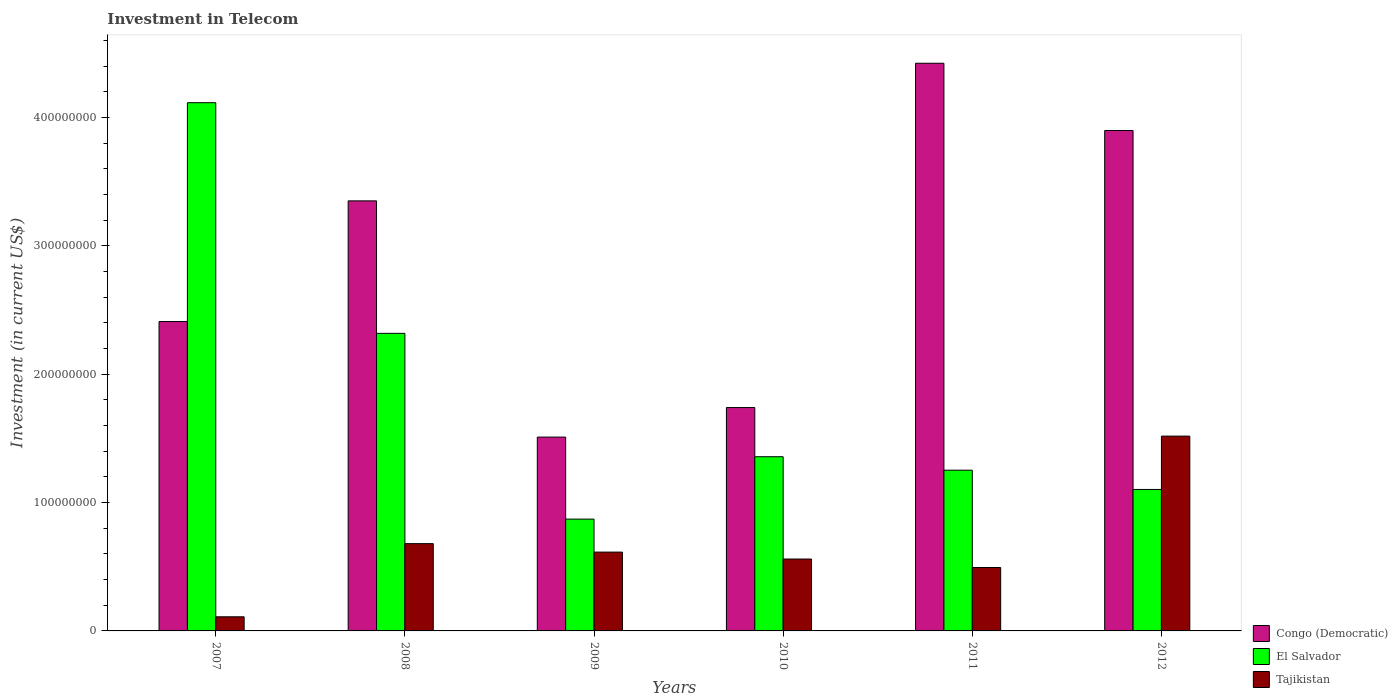Are the number of bars per tick equal to the number of legend labels?
Your answer should be very brief. Yes. Are the number of bars on each tick of the X-axis equal?
Your response must be concise. Yes. How many bars are there on the 6th tick from the left?
Offer a terse response. 3. In how many cases, is the number of bars for a given year not equal to the number of legend labels?
Your response must be concise. 0. What is the amount invested in telecom in Congo (Democratic) in 2009?
Your response must be concise. 1.51e+08. Across all years, what is the maximum amount invested in telecom in Tajikistan?
Offer a terse response. 1.52e+08. Across all years, what is the minimum amount invested in telecom in El Salvador?
Your answer should be compact. 8.71e+07. In which year was the amount invested in telecom in Congo (Democratic) minimum?
Offer a terse response. 2009. What is the total amount invested in telecom in El Salvador in the graph?
Your answer should be very brief. 1.10e+09. What is the difference between the amount invested in telecom in Congo (Democratic) in 2007 and that in 2012?
Keep it short and to the point. -1.49e+08. What is the difference between the amount invested in telecom in El Salvador in 2008 and the amount invested in telecom in Tajikistan in 2009?
Make the answer very short. 1.70e+08. What is the average amount invested in telecom in El Salvador per year?
Your answer should be compact. 1.84e+08. In the year 2011, what is the difference between the amount invested in telecom in Tajikistan and amount invested in telecom in El Salvador?
Make the answer very short. -7.58e+07. In how many years, is the amount invested in telecom in Congo (Democratic) greater than 60000000 US$?
Keep it short and to the point. 6. What is the ratio of the amount invested in telecom in Tajikistan in 2009 to that in 2011?
Your response must be concise. 1.24. Is the amount invested in telecom in Congo (Democratic) in 2010 less than that in 2012?
Offer a terse response. Yes. Is the difference between the amount invested in telecom in Tajikistan in 2011 and 2012 greater than the difference between the amount invested in telecom in El Salvador in 2011 and 2012?
Provide a succinct answer. No. What is the difference between the highest and the second highest amount invested in telecom in Congo (Democratic)?
Give a very brief answer. 5.24e+07. What is the difference between the highest and the lowest amount invested in telecom in Congo (Democratic)?
Give a very brief answer. 2.91e+08. What does the 2nd bar from the left in 2007 represents?
Offer a very short reply. El Salvador. What does the 3rd bar from the right in 2007 represents?
Provide a succinct answer. Congo (Democratic). How many bars are there?
Give a very brief answer. 18. Are all the bars in the graph horizontal?
Make the answer very short. No. Does the graph contain grids?
Keep it short and to the point. No. Where does the legend appear in the graph?
Provide a succinct answer. Bottom right. How many legend labels are there?
Offer a terse response. 3. What is the title of the graph?
Provide a succinct answer. Investment in Telecom. What is the label or title of the Y-axis?
Offer a very short reply. Investment (in current US$). What is the Investment (in current US$) in Congo (Democratic) in 2007?
Make the answer very short. 2.41e+08. What is the Investment (in current US$) of El Salvador in 2007?
Provide a short and direct response. 4.11e+08. What is the Investment (in current US$) of Tajikistan in 2007?
Provide a succinct answer. 1.10e+07. What is the Investment (in current US$) in Congo (Democratic) in 2008?
Provide a succinct answer. 3.35e+08. What is the Investment (in current US$) in El Salvador in 2008?
Keep it short and to the point. 2.32e+08. What is the Investment (in current US$) in Tajikistan in 2008?
Offer a terse response. 6.80e+07. What is the Investment (in current US$) in Congo (Democratic) in 2009?
Provide a succinct answer. 1.51e+08. What is the Investment (in current US$) of El Salvador in 2009?
Offer a terse response. 8.71e+07. What is the Investment (in current US$) in Tajikistan in 2009?
Offer a terse response. 6.14e+07. What is the Investment (in current US$) of Congo (Democratic) in 2010?
Provide a short and direct response. 1.74e+08. What is the Investment (in current US$) of El Salvador in 2010?
Provide a short and direct response. 1.36e+08. What is the Investment (in current US$) of Tajikistan in 2010?
Keep it short and to the point. 5.60e+07. What is the Investment (in current US$) in Congo (Democratic) in 2011?
Give a very brief answer. 4.42e+08. What is the Investment (in current US$) of El Salvador in 2011?
Provide a succinct answer. 1.25e+08. What is the Investment (in current US$) of Tajikistan in 2011?
Your response must be concise. 4.94e+07. What is the Investment (in current US$) in Congo (Democratic) in 2012?
Provide a short and direct response. 3.90e+08. What is the Investment (in current US$) in El Salvador in 2012?
Your answer should be very brief. 1.10e+08. What is the Investment (in current US$) in Tajikistan in 2012?
Keep it short and to the point. 1.52e+08. Across all years, what is the maximum Investment (in current US$) in Congo (Democratic)?
Make the answer very short. 4.42e+08. Across all years, what is the maximum Investment (in current US$) of El Salvador?
Keep it short and to the point. 4.11e+08. Across all years, what is the maximum Investment (in current US$) of Tajikistan?
Provide a succinct answer. 1.52e+08. Across all years, what is the minimum Investment (in current US$) in Congo (Democratic)?
Provide a succinct answer. 1.51e+08. Across all years, what is the minimum Investment (in current US$) of El Salvador?
Offer a terse response. 8.71e+07. Across all years, what is the minimum Investment (in current US$) of Tajikistan?
Offer a very short reply. 1.10e+07. What is the total Investment (in current US$) in Congo (Democratic) in the graph?
Offer a terse response. 1.73e+09. What is the total Investment (in current US$) of El Salvador in the graph?
Make the answer very short. 1.10e+09. What is the total Investment (in current US$) in Tajikistan in the graph?
Your answer should be compact. 3.98e+08. What is the difference between the Investment (in current US$) of Congo (Democratic) in 2007 and that in 2008?
Give a very brief answer. -9.40e+07. What is the difference between the Investment (in current US$) of El Salvador in 2007 and that in 2008?
Provide a short and direct response. 1.80e+08. What is the difference between the Investment (in current US$) in Tajikistan in 2007 and that in 2008?
Your answer should be compact. -5.70e+07. What is the difference between the Investment (in current US$) in Congo (Democratic) in 2007 and that in 2009?
Your answer should be very brief. 9.00e+07. What is the difference between the Investment (in current US$) of El Salvador in 2007 and that in 2009?
Your answer should be compact. 3.24e+08. What is the difference between the Investment (in current US$) in Tajikistan in 2007 and that in 2009?
Keep it short and to the point. -5.04e+07. What is the difference between the Investment (in current US$) of Congo (Democratic) in 2007 and that in 2010?
Offer a very short reply. 6.70e+07. What is the difference between the Investment (in current US$) of El Salvador in 2007 and that in 2010?
Your response must be concise. 2.76e+08. What is the difference between the Investment (in current US$) of Tajikistan in 2007 and that in 2010?
Your answer should be compact. -4.50e+07. What is the difference between the Investment (in current US$) in Congo (Democratic) in 2007 and that in 2011?
Provide a succinct answer. -2.01e+08. What is the difference between the Investment (in current US$) of El Salvador in 2007 and that in 2011?
Give a very brief answer. 2.86e+08. What is the difference between the Investment (in current US$) of Tajikistan in 2007 and that in 2011?
Your answer should be very brief. -3.84e+07. What is the difference between the Investment (in current US$) in Congo (Democratic) in 2007 and that in 2012?
Provide a short and direct response. -1.49e+08. What is the difference between the Investment (in current US$) of El Salvador in 2007 and that in 2012?
Offer a terse response. 3.01e+08. What is the difference between the Investment (in current US$) of Tajikistan in 2007 and that in 2012?
Ensure brevity in your answer.  -1.41e+08. What is the difference between the Investment (in current US$) in Congo (Democratic) in 2008 and that in 2009?
Provide a succinct answer. 1.84e+08. What is the difference between the Investment (in current US$) of El Salvador in 2008 and that in 2009?
Provide a succinct answer. 1.45e+08. What is the difference between the Investment (in current US$) in Tajikistan in 2008 and that in 2009?
Offer a terse response. 6.60e+06. What is the difference between the Investment (in current US$) of Congo (Democratic) in 2008 and that in 2010?
Your answer should be compact. 1.61e+08. What is the difference between the Investment (in current US$) of El Salvador in 2008 and that in 2010?
Ensure brevity in your answer.  9.61e+07. What is the difference between the Investment (in current US$) in Congo (Democratic) in 2008 and that in 2011?
Your response must be concise. -1.07e+08. What is the difference between the Investment (in current US$) of El Salvador in 2008 and that in 2011?
Offer a very short reply. 1.07e+08. What is the difference between the Investment (in current US$) of Tajikistan in 2008 and that in 2011?
Your answer should be compact. 1.86e+07. What is the difference between the Investment (in current US$) in Congo (Democratic) in 2008 and that in 2012?
Make the answer very short. -5.48e+07. What is the difference between the Investment (in current US$) of El Salvador in 2008 and that in 2012?
Provide a short and direct response. 1.22e+08. What is the difference between the Investment (in current US$) of Tajikistan in 2008 and that in 2012?
Give a very brief answer. -8.38e+07. What is the difference between the Investment (in current US$) in Congo (Democratic) in 2009 and that in 2010?
Your answer should be very brief. -2.30e+07. What is the difference between the Investment (in current US$) in El Salvador in 2009 and that in 2010?
Your answer should be very brief. -4.86e+07. What is the difference between the Investment (in current US$) in Tajikistan in 2009 and that in 2010?
Keep it short and to the point. 5.40e+06. What is the difference between the Investment (in current US$) of Congo (Democratic) in 2009 and that in 2011?
Give a very brief answer. -2.91e+08. What is the difference between the Investment (in current US$) of El Salvador in 2009 and that in 2011?
Offer a terse response. -3.81e+07. What is the difference between the Investment (in current US$) of Tajikistan in 2009 and that in 2011?
Provide a succinct answer. 1.20e+07. What is the difference between the Investment (in current US$) of Congo (Democratic) in 2009 and that in 2012?
Provide a succinct answer. -2.39e+08. What is the difference between the Investment (in current US$) of El Salvador in 2009 and that in 2012?
Provide a short and direct response. -2.31e+07. What is the difference between the Investment (in current US$) of Tajikistan in 2009 and that in 2012?
Ensure brevity in your answer.  -9.04e+07. What is the difference between the Investment (in current US$) in Congo (Democratic) in 2010 and that in 2011?
Give a very brief answer. -2.68e+08. What is the difference between the Investment (in current US$) of El Salvador in 2010 and that in 2011?
Your answer should be very brief. 1.05e+07. What is the difference between the Investment (in current US$) of Tajikistan in 2010 and that in 2011?
Provide a succinct answer. 6.60e+06. What is the difference between the Investment (in current US$) of Congo (Democratic) in 2010 and that in 2012?
Provide a succinct answer. -2.16e+08. What is the difference between the Investment (in current US$) in El Salvador in 2010 and that in 2012?
Offer a very short reply. 2.55e+07. What is the difference between the Investment (in current US$) in Tajikistan in 2010 and that in 2012?
Keep it short and to the point. -9.58e+07. What is the difference between the Investment (in current US$) of Congo (Democratic) in 2011 and that in 2012?
Give a very brief answer. 5.24e+07. What is the difference between the Investment (in current US$) of El Salvador in 2011 and that in 2012?
Provide a short and direct response. 1.50e+07. What is the difference between the Investment (in current US$) of Tajikistan in 2011 and that in 2012?
Provide a short and direct response. -1.02e+08. What is the difference between the Investment (in current US$) in Congo (Democratic) in 2007 and the Investment (in current US$) in El Salvador in 2008?
Give a very brief answer. 9.20e+06. What is the difference between the Investment (in current US$) in Congo (Democratic) in 2007 and the Investment (in current US$) in Tajikistan in 2008?
Provide a succinct answer. 1.73e+08. What is the difference between the Investment (in current US$) of El Salvador in 2007 and the Investment (in current US$) of Tajikistan in 2008?
Ensure brevity in your answer.  3.43e+08. What is the difference between the Investment (in current US$) in Congo (Democratic) in 2007 and the Investment (in current US$) in El Salvador in 2009?
Offer a terse response. 1.54e+08. What is the difference between the Investment (in current US$) in Congo (Democratic) in 2007 and the Investment (in current US$) in Tajikistan in 2009?
Your answer should be very brief. 1.80e+08. What is the difference between the Investment (in current US$) of El Salvador in 2007 and the Investment (in current US$) of Tajikistan in 2009?
Your answer should be compact. 3.50e+08. What is the difference between the Investment (in current US$) in Congo (Democratic) in 2007 and the Investment (in current US$) in El Salvador in 2010?
Give a very brief answer. 1.05e+08. What is the difference between the Investment (in current US$) in Congo (Democratic) in 2007 and the Investment (in current US$) in Tajikistan in 2010?
Offer a terse response. 1.85e+08. What is the difference between the Investment (in current US$) of El Salvador in 2007 and the Investment (in current US$) of Tajikistan in 2010?
Offer a very short reply. 3.55e+08. What is the difference between the Investment (in current US$) in Congo (Democratic) in 2007 and the Investment (in current US$) in El Salvador in 2011?
Provide a succinct answer. 1.16e+08. What is the difference between the Investment (in current US$) in Congo (Democratic) in 2007 and the Investment (in current US$) in Tajikistan in 2011?
Offer a terse response. 1.92e+08. What is the difference between the Investment (in current US$) in El Salvador in 2007 and the Investment (in current US$) in Tajikistan in 2011?
Provide a short and direct response. 3.62e+08. What is the difference between the Investment (in current US$) in Congo (Democratic) in 2007 and the Investment (in current US$) in El Salvador in 2012?
Give a very brief answer. 1.31e+08. What is the difference between the Investment (in current US$) of Congo (Democratic) in 2007 and the Investment (in current US$) of Tajikistan in 2012?
Offer a very short reply. 8.92e+07. What is the difference between the Investment (in current US$) of El Salvador in 2007 and the Investment (in current US$) of Tajikistan in 2012?
Give a very brief answer. 2.60e+08. What is the difference between the Investment (in current US$) in Congo (Democratic) in 2008 and the Investment (in current US$) in El Salvador in 2009?
Offer a terse response. 2.48e+08. What is the difference between the Investment (in current US$) of Congo (Democratic) in 2008 and the Investment (in current US$) of Tajikistan in 2009?
Your response must be concise. 2.74e+08. What is the difference between the Investment (in current US$) of El Salvador in 2008 and the Investment (in current US$) of Tajikistan in 2009?
Give a very brief answer. 1.70e+08. What is the difference between the Investment (in current US$) of Congo (Democratic) in 2008 and the Investment (in current US$) of El Salvador in 2010?
Ensure brevity in your answer.  1.99e+08. What is the difference between the Investment (in current US$) in Congo (Democratic) in 2008 and the Investment (in current US$) in Tajikistan in 2010?
Your response must be concise. 2.79e+08. What is the difference between the Investment (in current US$) of El Salvador in 2008 and the Investment (in current US$) of Tajikistan in 2010?
Offer a terse response. 1.76e+08. What is the difference between the Investment (in current US$) of Congo (Democratic) in 2008 and the Investment (in current US$) of El Salvador in 2011?
Your answer should be compact. 2.10e+08. What is the difference between the Investment (in current US$) in Congo (Democratic) in 2008 and the Investment (in current US$) in Tajikistan in 2011?
Give a very brief answer. 2.86e+08. What is the difference between the Investment (in current US$) of El Salvador in 2008 and the Investment (in current US$) of Tajikistan in 2011?
Ensure brevity in your answer.  1.82e+08. What is the difference between the Investment (in current US$) in Congo (Democratic) in 2008 and the Investment (in current US$) in El Salvador in 2012?
Make the answer very short. 2.25e+08. What is the difference between the Investment (in current US$) of Congo (Democratic) in 2008 and the Investment (in current US$) of Tajikistan in 2012?
Offer a very short reply. 1.83e+08. What is the difference between the Investment (in current US$) of El Salvador in 2008 and the Investment (in current US$) of Tajikistan in 2012?
Your response must be concise. 8.00e+07. What is the difference between the Investment (in current US$) in Congo (Democratic) in 2009 and the Investment (in current US$) in El Salvador in 2010?
Make the answer very short. 1.53e+07. What is the difference between the Investment (in current US$) of Congo (Democratic) in 2009 and the Investment (in current US$) of Tajikistan in 2010?
Make the answer very short. 9.50e+07. What is the difference between the Investment (in current US$) of El Salvador in 2009 and the Investment (in current US$) of Tajikistan in 2010?
Make the answer very short. 3.11e+07. What is the difference between the Investment (in current US$) in Congo (Democratic) in 2009 and the Investment (in current US$) in El Salvador in 2011?
Ensure brevity in your answer.  2.58e+07. What is the difference between the Investment (in current US$) of Congo (Democratic) in 2009 and the Investment (in current US$) of Tajikistan in 2011?
Your answer should be compact. 1.02e+08. What is the difference between the Investment (in current US$) in El Salvador in 2009 and the Investment (in current US$) in Tajikistan in 2011?
Provide a short and direct response. 3.77e+07. What is the difference between the Investment (in current US$) in Congo (Democratic) in 2009 and the Investment (in current US$) in El Salvador in 2012?
Offer a very short reply. 4.08e+07. What is the difference between the Investment (in current US$) in Congo (Democratic) in 2009 and the Investment (in current US$) in Tajikistan in 2012?
Provide a succinct answer. -7.50e+05. What is the difference between the Investment (in current US$) of El Salvador in 2009 and the Investment (in current US$) of Tajikistan in 2012?
Give a very brief answer. -6.46e+07. What is the difference between the Investment (in current US$) of Congo (Democratic) in 2010 and the Investment (in current US$) of El Salvador in 2011?
Offer a terse response. 4.88e+07. What is the difference between the Investment (in current US$) in Congo (Democratic) in 2010 and the Investment (in current US$) in Tajikistan in 2011?
Your answer should be very brief. 1.25e+08. What is the difference between the Investment (in current US$) of El Salvador in 2010 and the Investment (in current US$) of Tajikistan in 2011?
Keep it short and to the point. 8.63e+07. What is the difference between the Investment (in current US$) in Congo (Democratic) in 2010 and the Investment (in current US$) in El Salvador in 2012?
Provide a short and direct response. 6.38e+07. What is the difference between the Investment (in current US$) of Congo (Democratic) in 2010 and the Investment (in current US$) of Tajikistan in 2012?
Offer a very short reply. 2.22e+07. What is the difference between the Investment (in current US$) in El Salvador in 2010 and the Investment (in current US$) in Tajikistan in 2012?
Ensure brevity in your answer.  -1.60e+07. What is the difference between the Investment (in current US$) in Congo (Democratic) in 2011 and the Investment (in current US$) in El Salvador in 2012?
Make the answer very short. 3.32e+08. What is the difference between the Investment (in current US$) of Congo (Democratic) in 2011 and the Investment (in current US$) of Tajikistan in 2012?
Your answer should be compact. 2.90e+08. What is the difference between the Investment (in current US$) of El Salvador in 2011 and the Investment (in current US$) of Tajikistan in 2012?
Ensure brevity in your answer.  -2.66e+07. What is the average Investment (in current US$) in Congo (Democratic) per year?
Your response must be concise. 2.89e+08. What is the average Investment (in current US$) of El Salvador per year?
Give a very brief answer. 1.84e+08. What is the average Investment (in current US$) in Tajikistan per year?
Keep it short and to the point. 6.63e+07. In the year 2007, what is the difference between the Investment (in current US$) in Congo (Democratic) and Investment (in current US$) in El Salvador?
Offer a very short reply. -1.70e+08. In the year 2007, what is the difference between the Investment (in current US$) of Congo (Democratic) and Investment (in current US$) of Tajikistan?
Provide a succinct answer. 2.30e+08. In the year 2007, what is the difference between the Investment (in current US$) of El Salvador and Investment (in current US$) of Tajikistan?
Your answer should be compact. 4.00e+08. In the year 2008, what is the difference between the Investment (in current US$) of Congo (Democratic) and Investment (in current US$) of El Salvador?
Give a very brief answer. 1.03e+08. In the year 2008, what is the difference between the Investment (in current US$) of Congo (Democratic) and Investment (in current US$) of Tajikistan?
Give a very brief answer. 2.67e+08. In the year 2008, what is the difference between the Investment (in current US$) in El Salvador and Investment (in current US$) in Tajikistan?
Your response must be concise. 1.64e+08. In the year 2009, what is the difference between the Investment (in current US$) of Congo (Democratic) and Investment (in current US$) of El Salvador?
Offer a terse response. 6.39e+07. In the year 2009, what is the difference between the Investment (in current US$) in Congo (Democratic) and Investment (in current US$) in Tajikistan?
Give a very brief answer. 8.96e+07. In the year 2009, what is the difference between the Investment (in current US$) in El Salvador and Investment (in current US$) in Tajikistan?
Provide a succinct answer. 2.57e+07. In the year 2010, what is the difference between the Investment (in current US$) of Congo (Democratic) and Investment (in current US$) of El Salvador?
Offer a very short reply. 3.83e+07. In the year 2010, what is the difference between the Investment (in current US$) in Congo (Democratic) and Investment (in current US$) in Tajikistan?
Keep it short and to the point. 1.18e+08. In the year 2010, what is the difference between the Investment (in current US$) of El Salvador and Investment (in current US$) of Tajikistan?
Offer a very short reply. 7.97e+07. In the year 2011, what is the difference between the Investment (in current US$) in Congo (Democratic) and Investment (in current US$) in El Salvador?
Offer a terse response. 3.17e+08. In the year 2011, what is the difference between the Investment (in current US$) of Congo (Democratic) and Investment (in current US$) of Tajikistan?
Your response must be concise. 3.93e+08. In the year 2011, what is the difference between the Investment (in current US$) in El Salvador and Investment (in current US$) in Tajikistan?
Offer a very short reply. 7.58e+07. In the year 2012, what is the difference between the Investment (in current US$) of Congo (Democratic) and Investment (in current US$) of El Salvador?
Offer a terse response. 2.80e+08. In the year 2012, what is the difference between the Investment (in current US$) of Congo (Democratic) and Investment (in current US$) of Tajikistan?
Your response must be concise. 2.38e+08. In the year 2012, what is the difference between the Investment (in current US$) in El Salvador and Investment (in current US$) in Tajikistan?
Your answer should be very brief. -4.16e+07. What is the ratio of the Investment (in current US$) in Congo (Democratic) in 2007 to that in 2008?
Your answer should be compact. 0.72. What is the ratio of the Investment (in current US$) of El Salvador in 2007 to that in 2008?
Your answer should be very brief. 1.78. What is the ratio of the Investment (in current US$) of Tajikistan in 2007 to that in 2008?
Your response must be concise. 0.16. What is the ratio of the Investment (in current US$) in Congo (Democratic) in 2007 to that in 2009?
Your answer should be compact. 1.6. What is the ratio of the Investment (in current US$) of El Salvador in 2007 to that in 2009?
Ensure brevity in your answer.  4.72. What is the ratio of the Investment (in current US$) in Tajikistan in 2007 to that in 2009?
Your answer should be very brief. 0.18. What is the ratio of the Investment (in current US$) in Congo (Democratic) in 2007 to that in 2010?
Your answer should be very brief. 1.39. What is the ratio of the Investment (in current US$) in El Salvador in 2007 to that in 2010?
Your answer should be compact. 3.03. What is the ratio of the Investment (in current US$) of Tajikistan in 2007 to that in 2010?
Ensure brevity in your answer.  0.2. What is the ratio of the Investment (in current US$) in Congo (Democratic) in 2007 to that in 2011?
Offer a very short reply. 0.55. What is the ratio of the Investment (in current US$) of El Salvador in 2007 to that in 2011?
Your answer should be very brief. 3.29. What is the ratio of the Investment (in current US$) in Tajikistan in 2007 to that in 2011?
Make the answer very short. 0.22. What is the ratio of the Investment (in current US$) in Congo (Democratic) in 2007 to that in 2012?
Your response must be concise. 0.62. What is the ratio of the Investment (in current US$) of El Salvador in 2007 to that in 2012?
Offer a terse response. 3.73. What is the ratio of the Investment (in current US$) in Tajikistan in 2007 to that in 2012?
Ensure brevity in your answer.  0.07. What is the ratio of the Investment (in current US$) of Congo (Democratic) in 2008 to that in 2009?
Your answer should be very brief. 2.22. What is the ratio of the Investment (in current US$) of El Salvador in 2008 to that in 2009?
Your answer should be very brief. 2.66. What is the ratio of the Investment (in current US$) of Tajikistan in 2008 to that in 2009?
Give a very brief answer. 1.11. What is the ratio of the Investment (in current US$) in Congo (Democratic) in 2008 to that in 2010?
Make the answer very short. 1.93. What is the ratio of the Investment (in current US$) of El Salvador in 2008 to that in 2010?
Offer a very short reply. 1.71. What is the ratio of the Investment (in current US$) in Tajikistan in 2008 to that in 2010?
Provide a succinct answer. 1.21. What is the ratio of the Investment (in current US$) in Congo (Democratic) in 2008 to that in 2011?
Your response must be concise. 0.76. What is the ratio of the Investment (in current US$) of El Salvador in 2008 to that in 2011?
Ensure brevity in your answer.  1.85. What is the ratio of the Investment (in current US$) of Tajikistan in 2008 to that in 2011?
Ensure brevity in your answer.  1.38. What is the ratio of the Investment (in current US$) in Congo (Democratic) in 2008 to that in 2012?
Offer a very short reply. 0.86. What is the ratio of the Investment (in current US$) of El Salvador in 2008 to that in 2012?
Give a very brief answer. 2.1. What is the ratio of the Investment (in current US$) of Tajikistan in 2008 to that in 2012?
Provide a short and direct response. 0.45. What is the ratio of the Investment (in current US$) of Congo (Democratic) in 2009 to that in 2010?
Give a very brief answer. 0.87. What is the ratio of the Investment (in current US$) in El Salvador in 2009 to that in 2010?
Provide a short and direct response. 0.64. What is the ratio of the Investment (in current US$) of Tajikistan in 2009 to that in 2010?
Ensure brevity in your answer.  1.1. What is the ratio of the Investment (in current US$) in Congo (Democratic) in 2009 to that in 2011?
Your answer should be very brief. 0.34. What is the ratio of the Investment (in current US$) of El Salvador in 2009 to that in 2011?
Ensure brevity in your answer.  0.7. What is the ratio of the Investment (in current US$) in Tajikistan in 2009 to that in 2011?
Your answer should be compact. 1.24. What is the ratio of the Investment (in current US$) in Congo (Democratic) in 2009 to that in 2012?
Offer a very short reply. 0.39. What is the ratio of the Investment (in current US$) in El Salvador in 2009 to that in 2012?
Give a very brief answer. 0.79. What is the ratio of the Investment (in current US$) of Tajikistan in 2009 to that in 2012?
Provide a succinct answer. 0.4. What is the ratio of the Investment (in current US$) in Congo (Democratic) in 2010 to that in 2011?
Your answer should be very brief. 0.39. What is the ratio of the Investment (in current US$) in El Salvador in 2010 to that in 2011?
Ensure brevity in your answer.  1.08. What is the ratio of the Investment (in current US$) in Tajikistan in 2010 to that in 2011?
Make the answer very short. 1.13. What is the ratio of the Investment (in current US$) in Congo (Democratic) in 2010 to that in 2012?
Your response must be concise. 0.45. What is the ratio of the Investment (in current US$) in El Salvador in 2010 to that in 2012?
Your answer should be compact. 1.23. What is the ratio of the Investment (in current US$) of Tajikistan in 2010 to that in 2012?
Your answer should be compact. 0.37. What is the ratio of the Investment (in current US$) in Congo (Democratic) in 2011 to that in 2012?
Your response must be concise. 1.13. What is the ratio of the Investment (in current US$) in El Salvador in 2011 to that in 2012?
Your response must be concise. 1.14. What is the ratio of the Investment (in current US$) in Tajikistan in 2011 to that in 2012?
Your answer should be very brief. 0.33. What is the difference between the highest and the second highest Investment (in current US$) of Congo (Democratic)?
Offer a very short reply. 5.24e+07. What is the difference between the highest and the second highest Investment (in current US$) in El Salvador?
Provide a succinct answer. 1.80e+08. What is the difference between the highest and the second highest Investment (in current US$) of Tajikistan?
Your response must be concise. 8.38e+07. What is the difference between the highest and the lowest Investment (in current US$) in Congo (Democratic)?
Your answer should be compact. 2.91e+08. What is the difference between the highest and the lowest Investment (in current US$) in El Salvador?
Your answer should be compact. 3.24e+08. What is the difference between the highest and the lowest Investment (in current US$) in Tajikistan?
Your answer should be compact. 1.41e+08. 